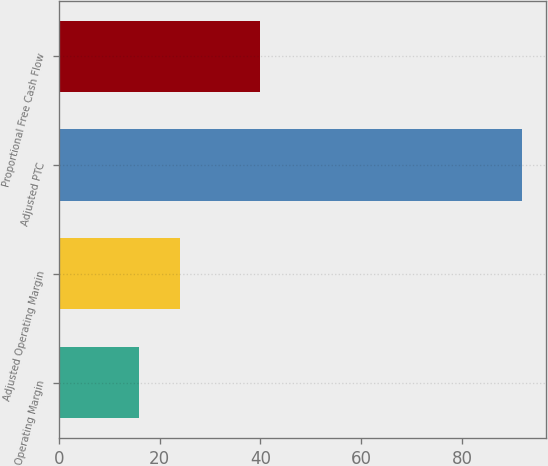Convert chart to OTSL. <chart><loc_0><loc_0><loc_500><loc_500><bar_chart><fcel>Operating Margin<fcel>Adjusted Operating Margin<fcel>Adjusted PTC<fcel>Proportional Free Cash Flow<nl><fcel>16<fcel>24<fcel>92<fcel>40<nl></chart> 